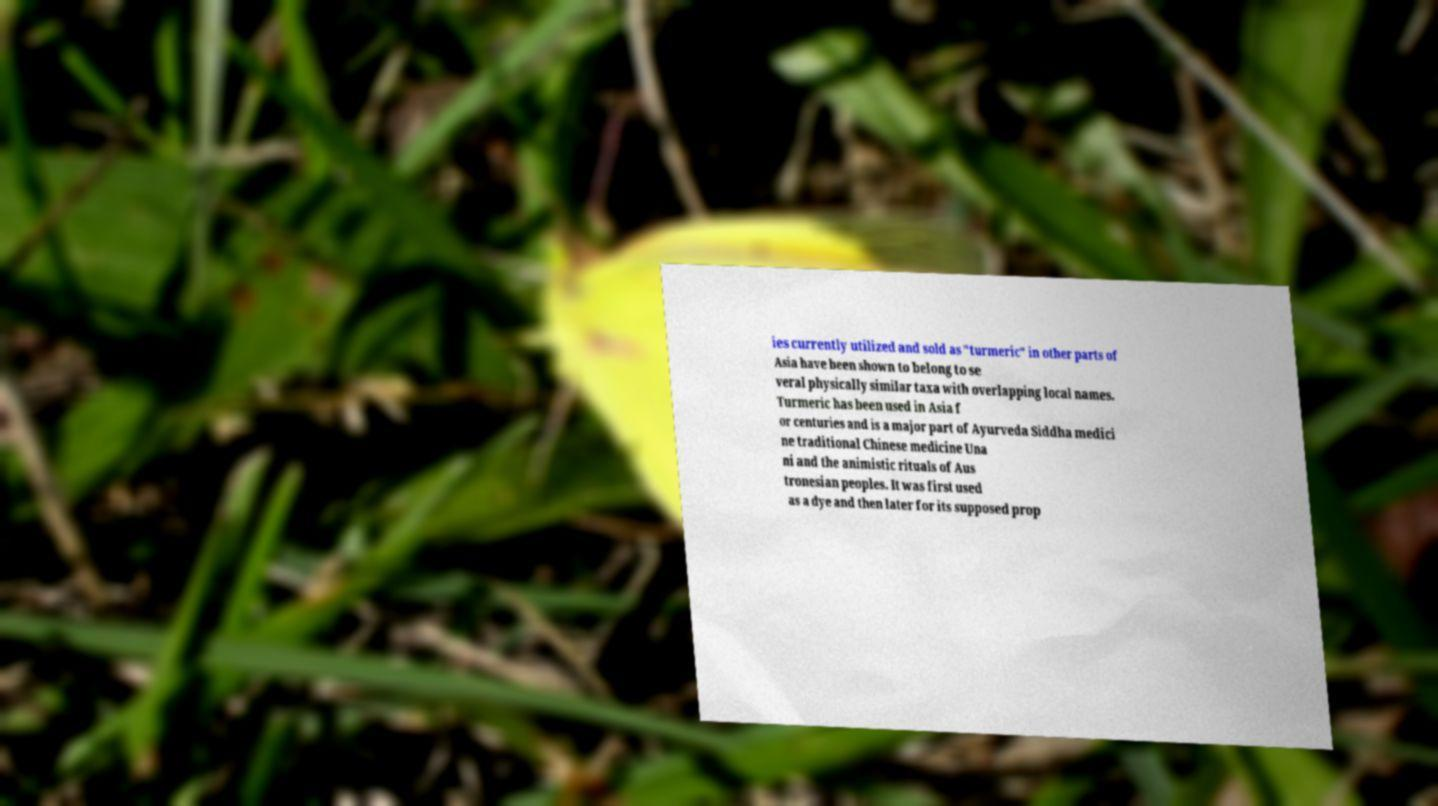I need the written content from this picture converted into text. Can you do that? ies currently utilized and sold as "turmeric" in other parts of Asia have been shown to belong to se veral physically similar taxa with overlapping local names. Turmeric has been used in Asia f or centuries and is a major part of Ayurveda Siddha medici ne traditional Chinese medicine Una ni and the animistic rituals of Aus tronesian peoples. It was first used as a dye and then later for its supposed prop 